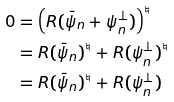<formula> <loc_0><loc_0><loc_500><loc_500>0 & = \left ( R ( \bar { \psi } _ { n } + \psi _ { n } ^ { \bot } ) \right ) ^ { \natural } \\ & = R ( \bar { \psi } _ { n } ) ^ { \natural } + R ( \psi _ { n } ^ { \bot } ) ^ { \natural } \\ & = R ( \bar { \psi } _ { n } ) ^ { \natural } + R ( \psi _ { n } ^ { \bot } )</formula> 